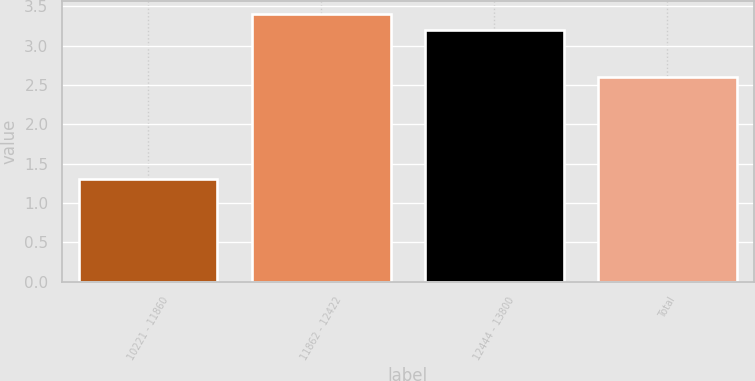<chart> <loc_0><loc_0><loc_500><loc_500><bar_chart><fcel>10221 - 11860<fcel>11862 - 12422<fcel>12444 - 13800<fcel>Total<nl><fcel>1.3<fcel>3.4<fcel>3.2<fcel>2.6<nl></chart> 